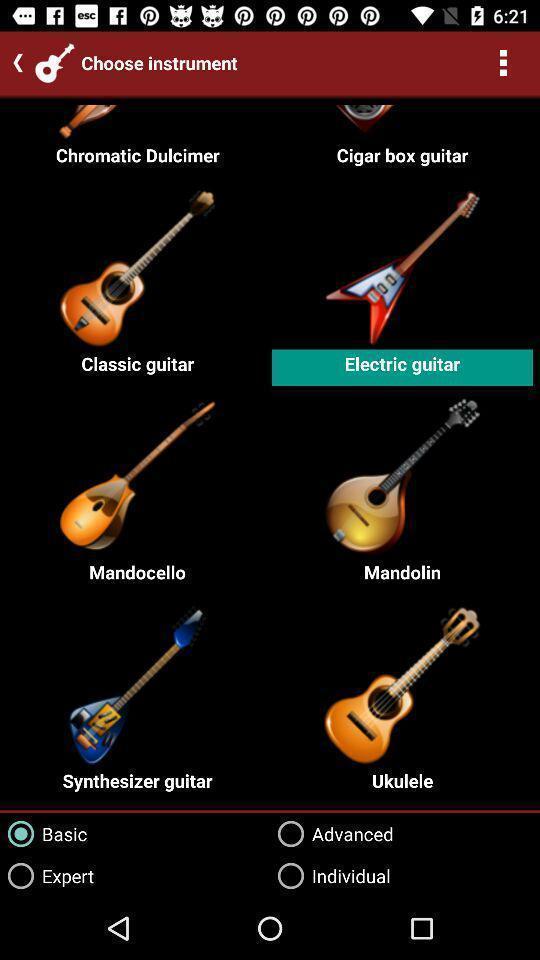Tell me what you see in this picture. Screen displaying multiple guitar images with names. 